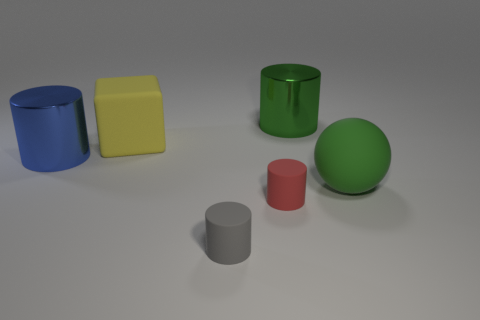Subtract all big blue cylinders. How many cylinders are left? 3 Add 1 blue metallic things. How many objects exist? 7 Subtract all green cylinders. How many cylinders are left? 3 Subtract 2 cylinders. How many cylinders are left? 2 Subtract all cylinders. How many objects are left? 2 Subtract all blue cylinders. Subtract all blue spheres. How many cylinders are left? 3 Add 2 purple spheres. How many purple spheres exist? 2 Subtract 0 yellow spheres. How many objects are left? 6 Subtract all small purple cubes. Subtract all large green things. How many objects are left? 4 Add 6 big objects. How many big objects are left? 10 